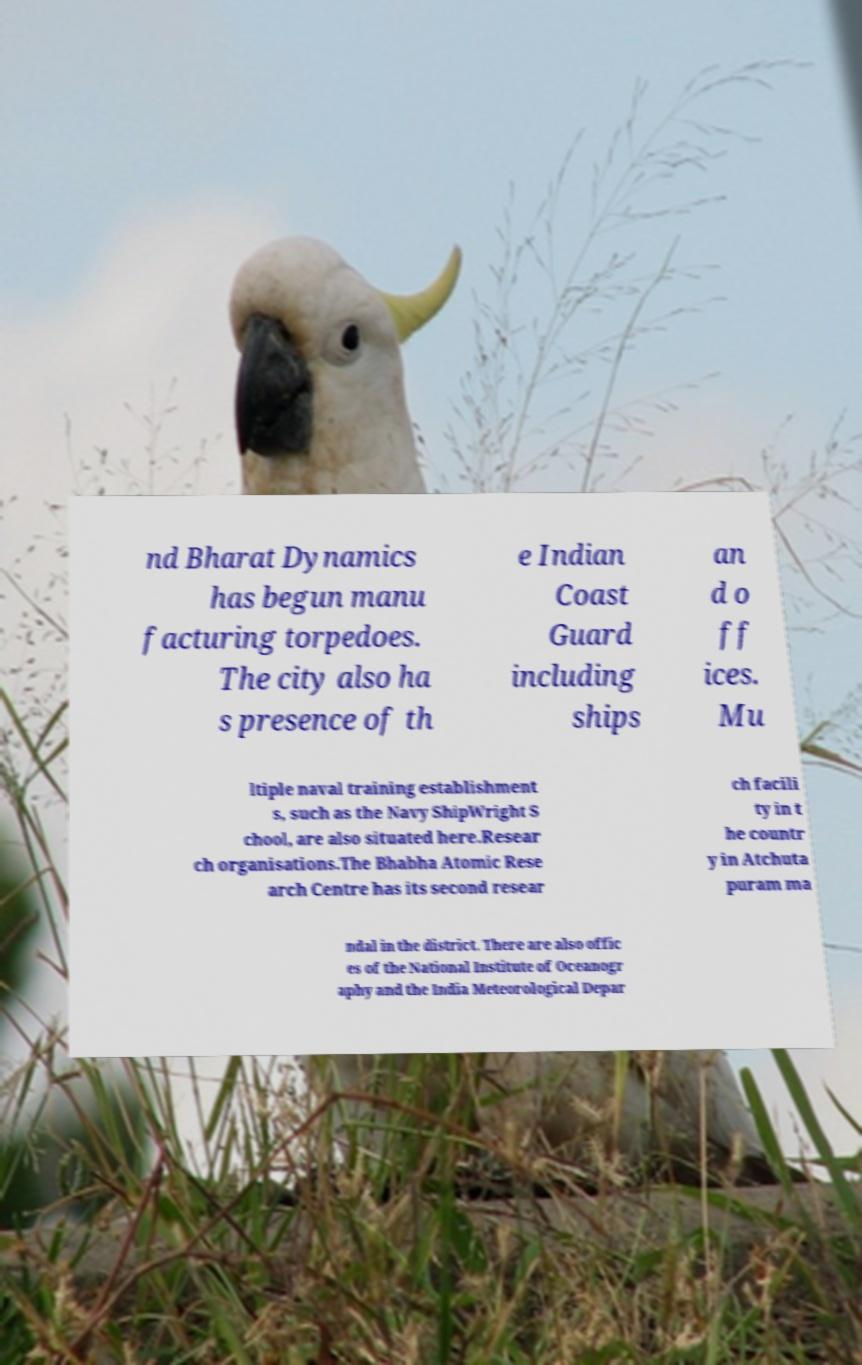For documentation purposes, I need the text within this image transcribed. Could you provide that? nd Bharat Dynamics has begun manu facturing torpedoes. The city also ha s presence of th e Indian Coast Guard including ships an d o ff ices. Mu ltiple naval training establishment s, such as the Navy ShipWright S chool, are also situated here.Resear ch organisations.The Bhabha Atomic Rese arch Centre has its second resear ch facili ty in t he countr y in Atchuta puram ma ndal in the district. There are also offic es of the National Institute of Oceanogr aphy and the India Meteorological Depar 